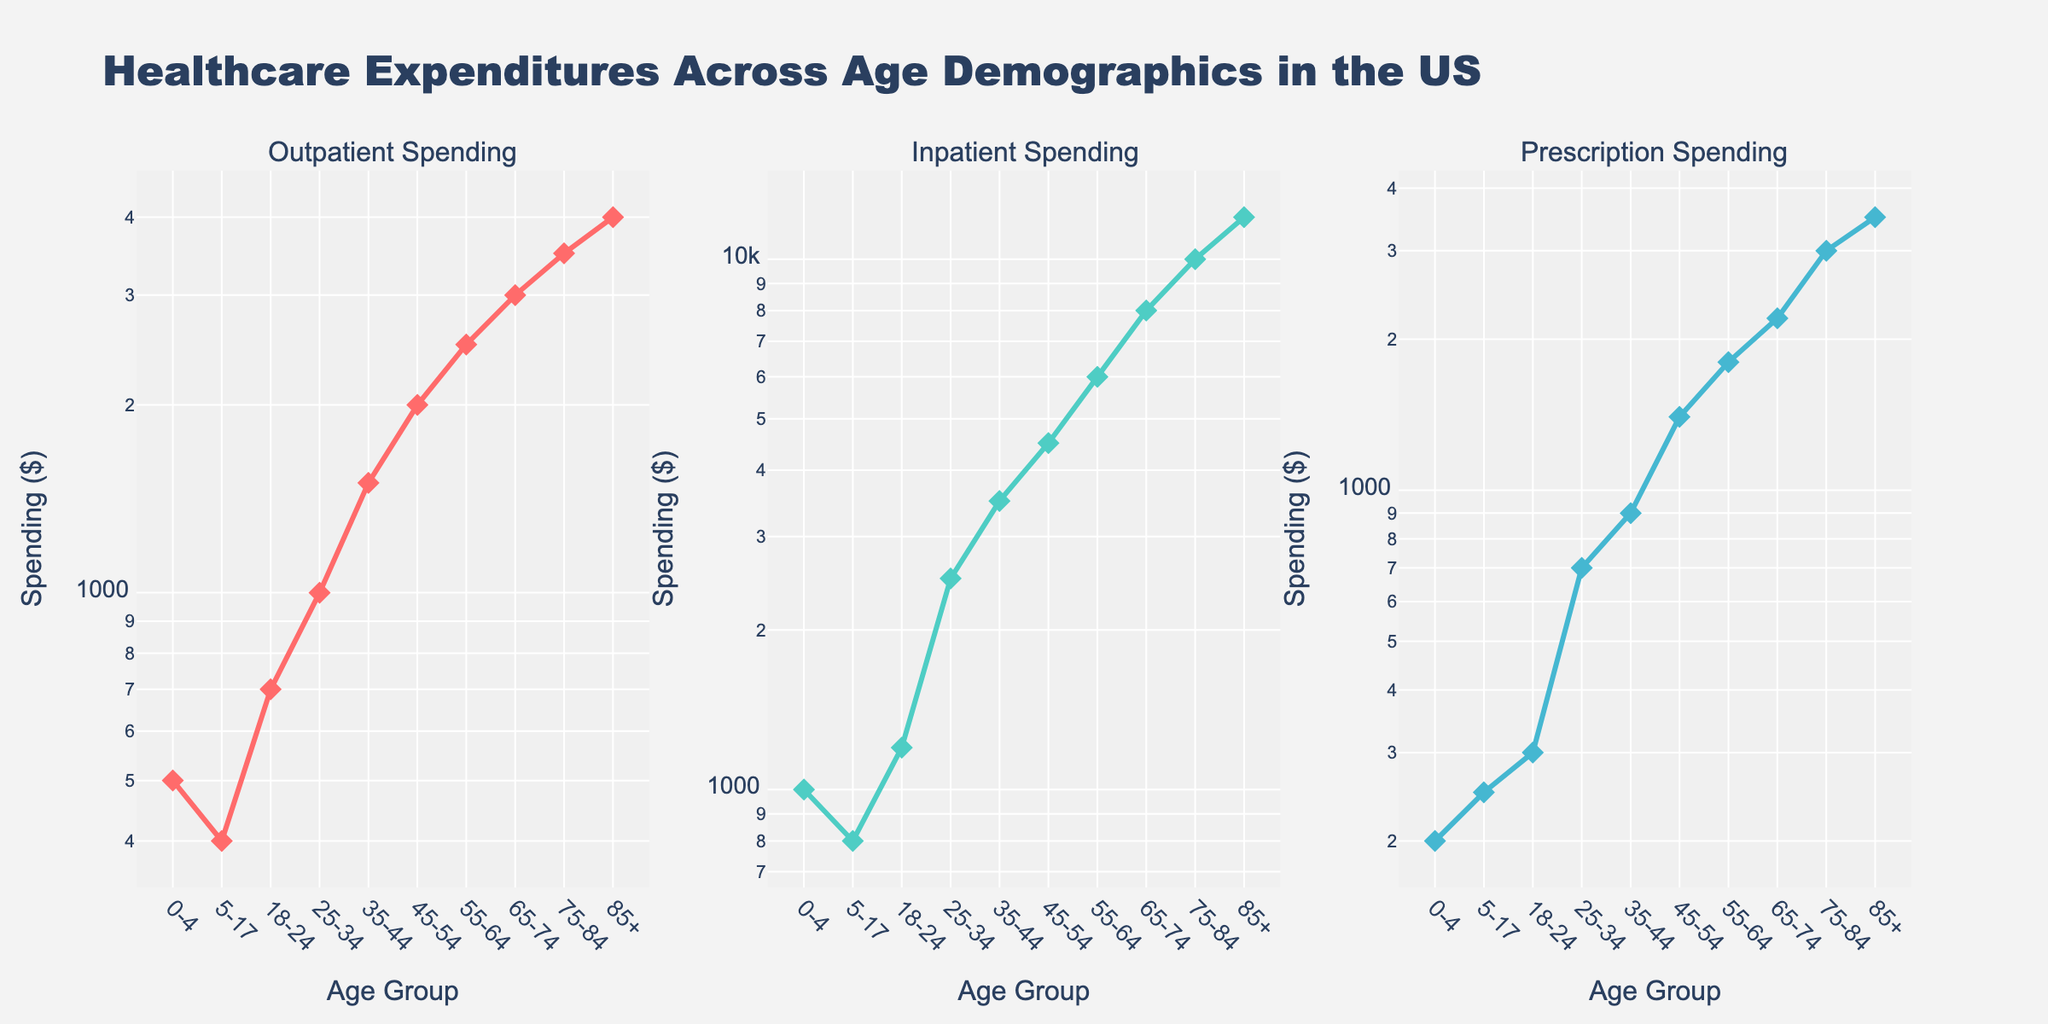What's the title of the figure? The title is usually located at the top of the figure. In this case, it reads "Healthcare Expenditures Across Age Demographics in the US" as provided in the plot generation code.
Answer: Healthcare Expenditures Across Age Demographics in the US How many subplots are present in the figure? The figure has a row with three columns. Each column has its own subplot. Therefore, there are 3 subplots.
Answer: 3 What's the age group with the highest outpatient spending? Checking the data points on the first subplot, the age group 85+ has the highest outpatient spending.
Answer: 85+ Which age group has the lowest prescription spending? In the third subplot focusing on prescription spending, the lowest value appears for the age group 0-4.
Answer: 0-4 How does inpatient spending compare between ages 25-34 and 75-84? The inpatient spending for the age group 25-34 is $2500, whereas for the age group 75-84 it is $10000, thus the spending for 75-84 is significantly higher.
Answer: 75-84 has higher inpatient spending At what age does outpatient spending surpass $1000? Inspecting the first subplot, outpatient spending surpasses $1000 starting from the age group 25-34.
Answer: 25-34 What's the difference between inpatient spending for ages 55-64 and 18-24? In the second subplot, inpatient spending for ages 55-64 is $6000 and for 18-24 it is $1200. The difference is therefore $6000 - $1200 = $4800.
Answer: $4800 What pattern do you notice in prescription spending across age groups? In the third subplot, prescription spending generally increases with age, starting at $200 and peaking at $3500 for the age group 85+.
Answer: Increases with age If someone is aged 45-54, how much more are they likely to spend on outpatient services compared to prescriptions? For age group 45-54, outpatient spending is $2000 and prescription spending is $1400. The difference is $2000 - $1400 = $600.
Answer: $600 more Is the expenditure data presented in fixed intervals across age groups? The age groups vary with no fixed interval, ranging from shorter periods (e.g., 0-4, 5-17) to consistent 10-year intervals (e.g., 35-44, 45-54).
Answer: No 